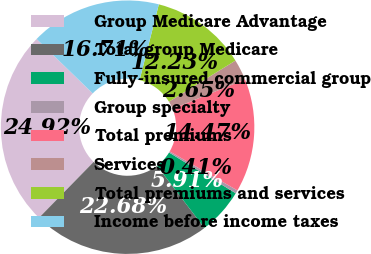Convert chart. <chart><loc_0><loc_0><loc_500><loc_500><pie_chart><fcel>Group Medicare Advantage<fcel>Total group Medicare<fcel>Fully-insured commercial group<fcel>Group specialty<fcel>Total premiums<fcel>Services<fcel>Total premiums and services<fcel>Income before income taxes<nl><fcel>24.92%<fcel>22.68%<fcel>5.91%<fcel>0.41%<fcel>14.47%<fcel>2.65%<fcel>12.23%<fcel>16.71%<nl></chart> 